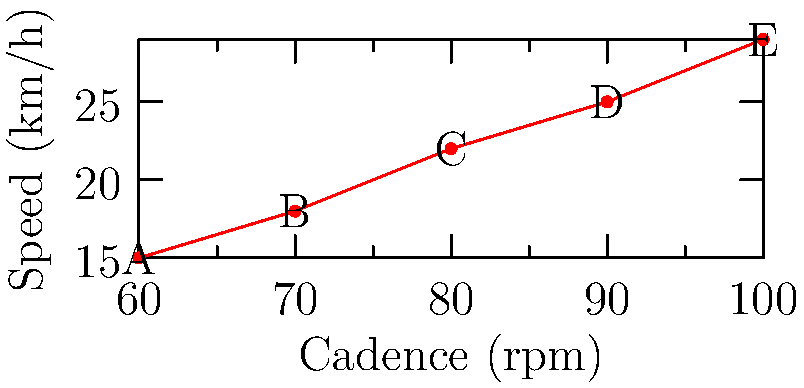The scatter plot shows the relationship between cadence (pedaling rate) and speed for different gear ratios on a bicycle. Which point on the graph represents the most efficient gear ratio for a comfortable ride? To determine the most efficient gear ratio for a comfortable ride, we need to consider the following:

1. Cadence: A comfortable cadence for most cyclists is around 80-90 rpm.
2. Speed: We want a reasonable speed without overexertion.
3. Efficiency: We're looking for a balance between cadence and speed.

Let's analyze each point:

A (60 rpm, 15 km/h): Too low cadence, slow speed.
B (70 rpm, 18 km/h): Better, but still low cadence.
C (80 rpm, 22 km/h): Good cadence, reasonable speed.
D (90 rpm, 25 km/h): Excellent cadence, good speed.
E (100 rpm, 29 km/h): High cadence, may be too intense for a novice.

Point D (90 rpm, 25 km/h) offers the best balance of comfortable cadence and good speed for a novice rider. It's within the optimal cadence range (80-90 rpm) and provides a decent speed without being too intense.
Answer: Point D (90 rpm, 25 km/h) 